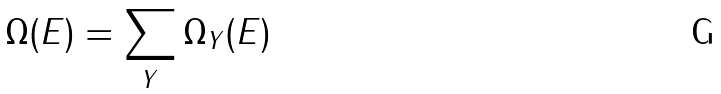Convert formula to latex. <formula><loc_0><loc_0><loc_500><loc_500>\Omega ( E ) = \sum _ { Y } \Omega _ { Y } ( E )</formula> 